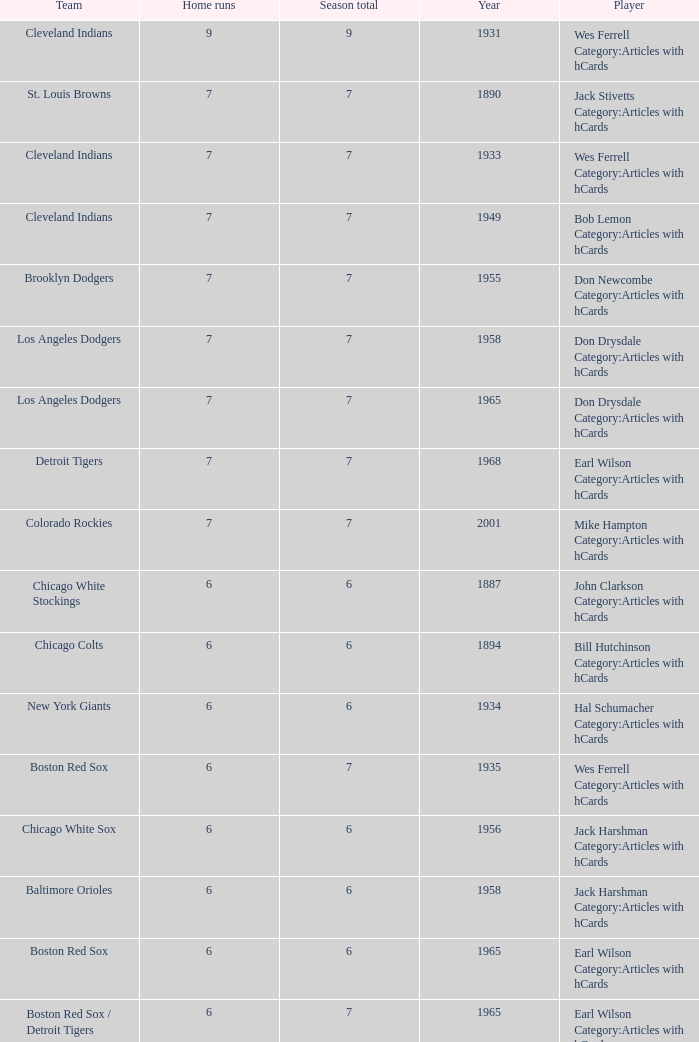Tell me the highest home runs for cleveland indians years before 1931 None. 